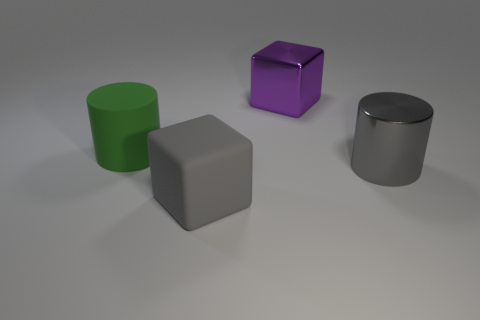Add 2 green matte objects. How many objects exist? 6 Subtract all large yellow metal cylinders. Subtract all large purple metallic cubes. How many objects are left? 3 Add 3 purple blocks. How many purple blocks are left? 4 Add 1 blue shiny spheres. How many blue shiny spheres exist? 1 Subtract 1 purple cubes. How many objects are left? 3 